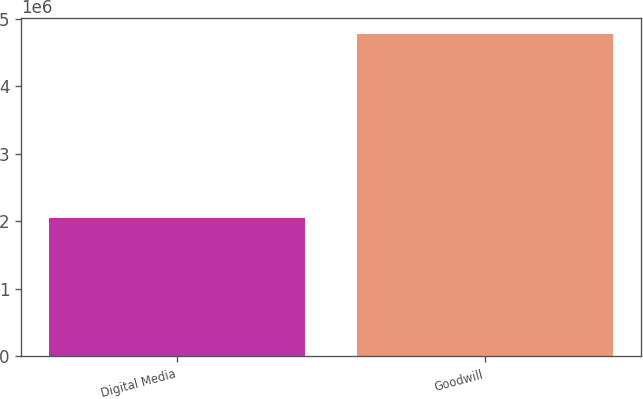<chart> <loc_0><loc_0><loc_500><loc_500><bar_chart><fcel>Digital Media<fcel>Goodwill<nl><fcel>2.04973e+06<fcel>4.77198e+06<nl></chart> 